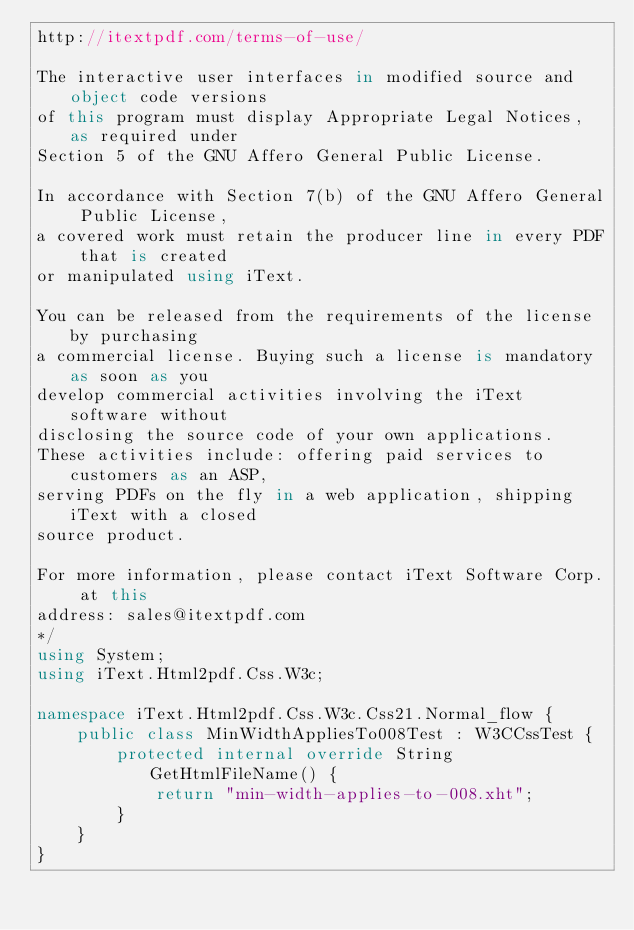<code> <loc_0><loc_0><loc_500><loc_500><_C#_>http://itextpdf.com/terms-of-use/

The interactive user interfaces in modified source and object code versions
of this program must display Appropriate Legal Notices, as required under
Section 5 of the GNU Affero General Public License.

In accordance with Section 7(b) of the GNU Affero General Public License,
a covered work must retain the producer line in every PDF that is created
or manipulated using iText.

You can be released from the requirements of the license by purchasing
a commercial license. Buying such a license is mandatory as soon as you
develop commercial activities involving the iText software without
disclosing the source code of your own applications.
These activities include: offering paid services to customers as an ASP,
serving PDFs on the fly in a web application, shipping iText with a closed
source product.

For more information, please contact iText Software Corp. at this
address: sales@itextpdf.com
*/
using System;
using iText.Html2pdf.Css.W3c;

namespace iText.Html2pdf.Css.W3c.Css21.Normal_flow {
    public class MinWidthAppliesTo008Test : W3CCssTest {
        protected internal override String GetHtmlFileName() {
            return "min-width-applies-to-008.xht";
        }
    }
}
</code> 